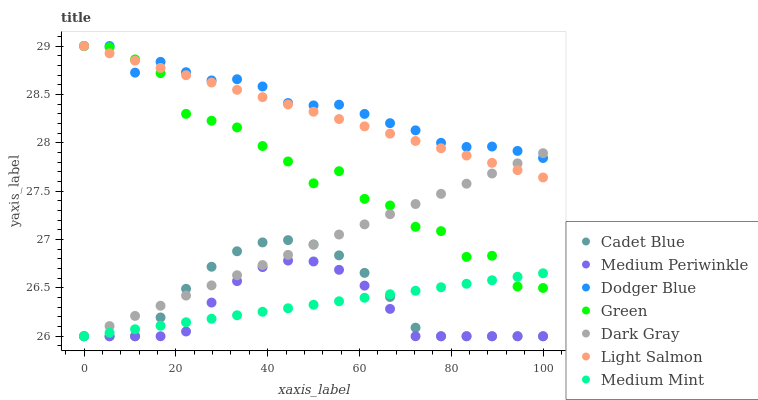Does Medium Periwinkle have the minimum area under the curve?
Answer yes or no. Yes. Does Dodger Blue have the maximum area under the curve?
Answer yes or no. Yes. Does Light Salmon have the minimum area under the curve?
Answer yes or no. No. Does Light Salmon have the maximum area under the curve?
Answer yes or no. No. Is Medium Mint the smoothest?
Answer yes or no. Yes. Is Green the roughest?
Answer yes or no. Yes. Is Light Salmon the smoothest?
Answer yes or no. No. Is Light Salmon the roughest?
Answer yes or no. No. Does Medium Mint have the lowest value?
Answer yes or no. Yes. Does Light Salmon have the lowest value?
Answer yes or no. No. Does Green have the highest value?
Answer yes or no. Yes. Does Cadet Blue have the highest value?
Answer yes or no. No. Is Medium Periwinkle less than Light Salmon?
Answer yes or no. Yes. Is Light Salmon greater than Medium Periwinkle?
Answer yes or no. Yes. Does Medium Mint intersect Dark Gray?
Answer yes or no. Yes. Is Medium Mint less than Dark Gray?
Answer yes or no. No. Is Medium Mint greater than Dark Gray?
Answer yes or no. No. Does Medium Periwinkle intersect Light Salmon?
Answer yes or no. No. 